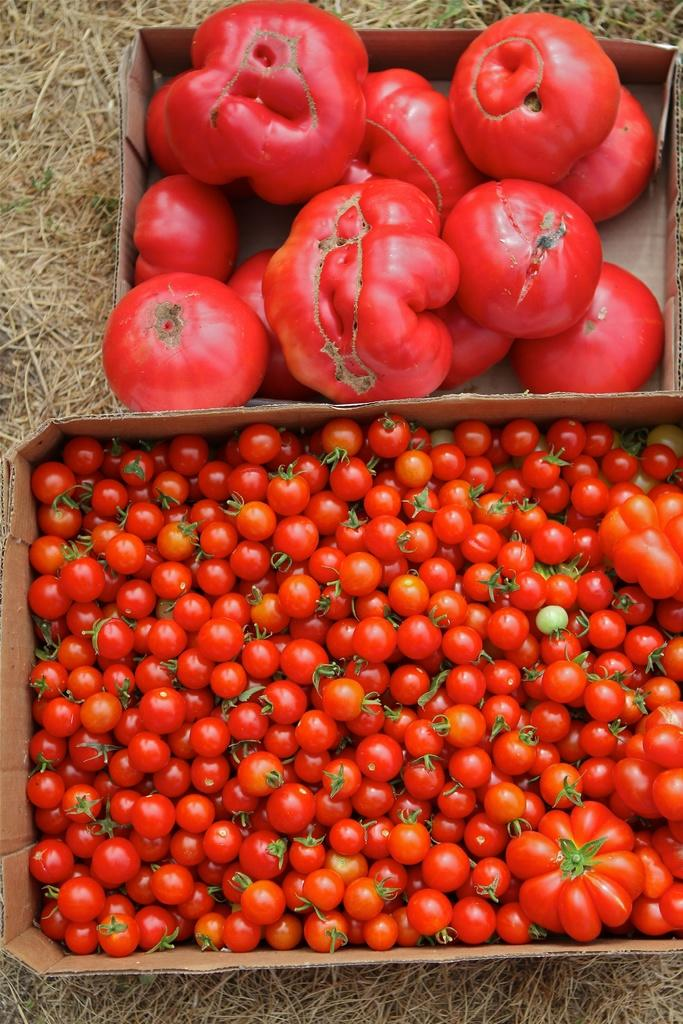What type of fruit is present in the image? There are tomatoes in the image. How are the tomatoes stored in the image? The tomatoes are in cardboard boxes. What is the surface on which the cardboard boxes are placed? The cardboard boxes are on dried grass. How many eyes can be seen on the cactus in the image? There is no cactus present in the image, so it is not possible to determine the number of eyes on a cactus. 